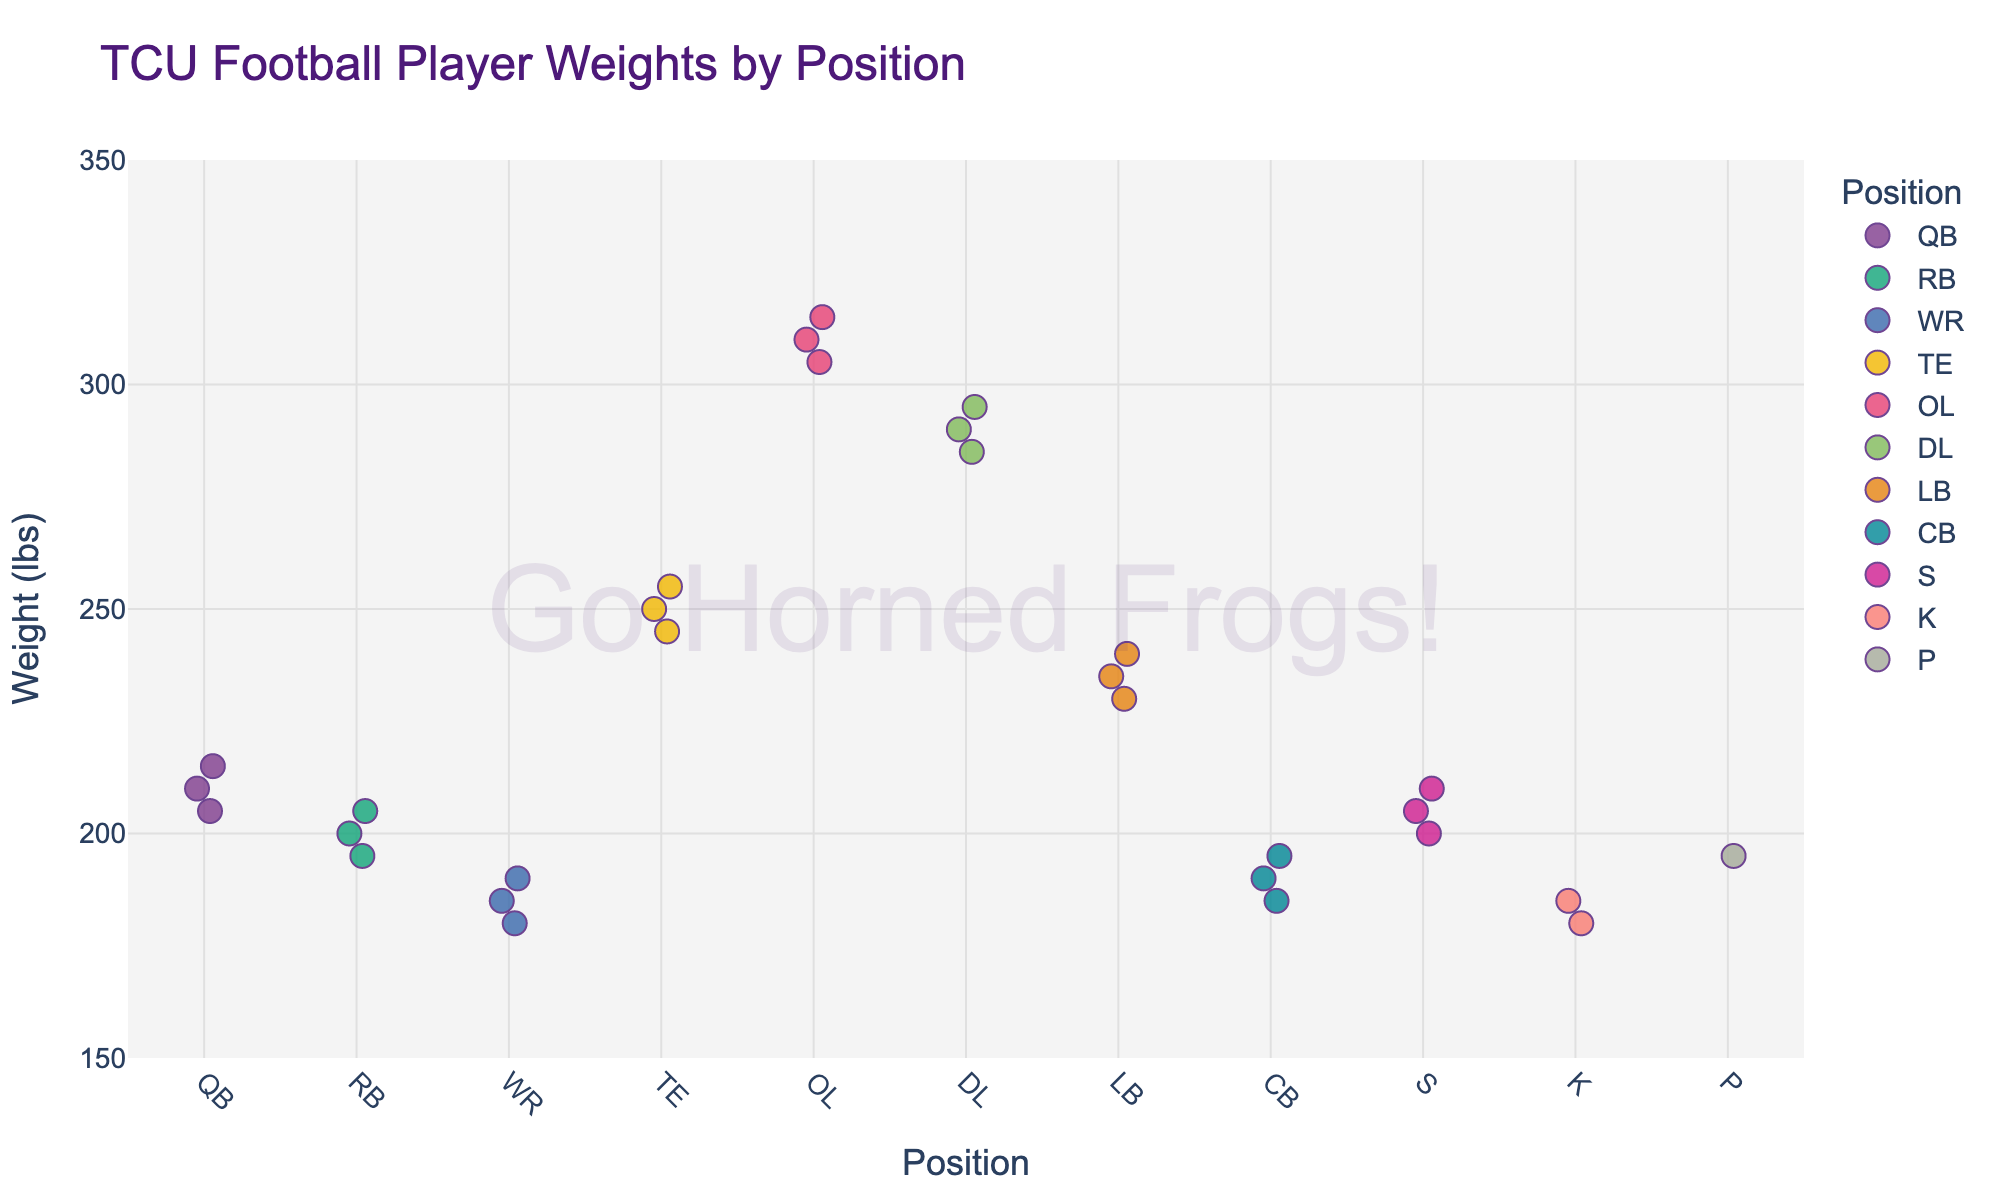What's the title of the plot? The title of the plot is usually located at the top of the figure and is clearly labeled. In this case, it is indicated in the code where it says `title="TCU Football Player Weights by Position"`.
Answer: TCU Football Player Weights by Position What are the labels of the x-axis and y-axis? The labels are specified in the code where it says `labels={"Weight": "Weight (lbs)"}` and `x="Position"`. Therefore, the x-axis is labeled "Position" and the y-axis is labeled "Weight (lbs)".
Answer: Position (x-axis), Weight (lbs) (y-axis) How many different player positions are shown? The different positions are defined by unique categories on the x-axis. By examining the data or plot, we can count the unique positions: QB, RB, WR, TE, OL, DL, LB, CB, S, K, P.
Answer: 10 Which position has the heaviest player, and what is their weight? By inspecting the distribution of weights, we look for the maximum weight data point and note the corresponding position. The heaviest weight is 315 lbs for the OL position.
Answer: OL, 315 lbs Which position has the lightest player, and what is their weight? By looking for the minimum weight data point, we can identify that the position with the lightest player is WR at 180 lbs.
Answer: WR, 180 lbs What is the range of weights for the TE position? For the TE position, find the minimum and maximum weights. The weights for TE players are 245, 250, and 255 lbs. So, the range is 255 - 245 = 10 lbs.
Answer: 10 lbs How does the average weight of OL players compare to that of QB players? Calculate the average weight of OL players: (305 + 310 + 315) / 3 = 310 lbs. Calculate the average weight of QB players: (205 + 210 + 215) / 3 = 210 lbs. Compare the two averages: 310 lbs (OL) is heavier than 210 lbs (QB).
Answer: OL players are heavier by 100 lbs Are there any positions with identical player weights? Check each position's weight data points and identify any duplicates across different categories. Both WR and K have a player of 185 lbs.
Answer: Yes, WR and K (185 lbs) What can you infer about the relationship between player positions and their weights? By analyzing the spread and concentration of data points for each position, you can infer that positions like OL and DL have higher weights, which suggests a need for greater mass in these roles, while positions like WR and K tend to have lower weights, implying agility and speed are more important.
Answer: Heavier positions: OL, DL; Lighter positions: WR, K Compare the weight range of RB players to that of QB players. For RB: minimum 195 lbs, maximum 205 lbs. Range: 205 - 195 = 10 lbs. For QB: minimum 205 lbs, maximum 215 lbs. Range: 215 - 205 = 10 lbs.
Answer: Both have a range of 10 lbs 